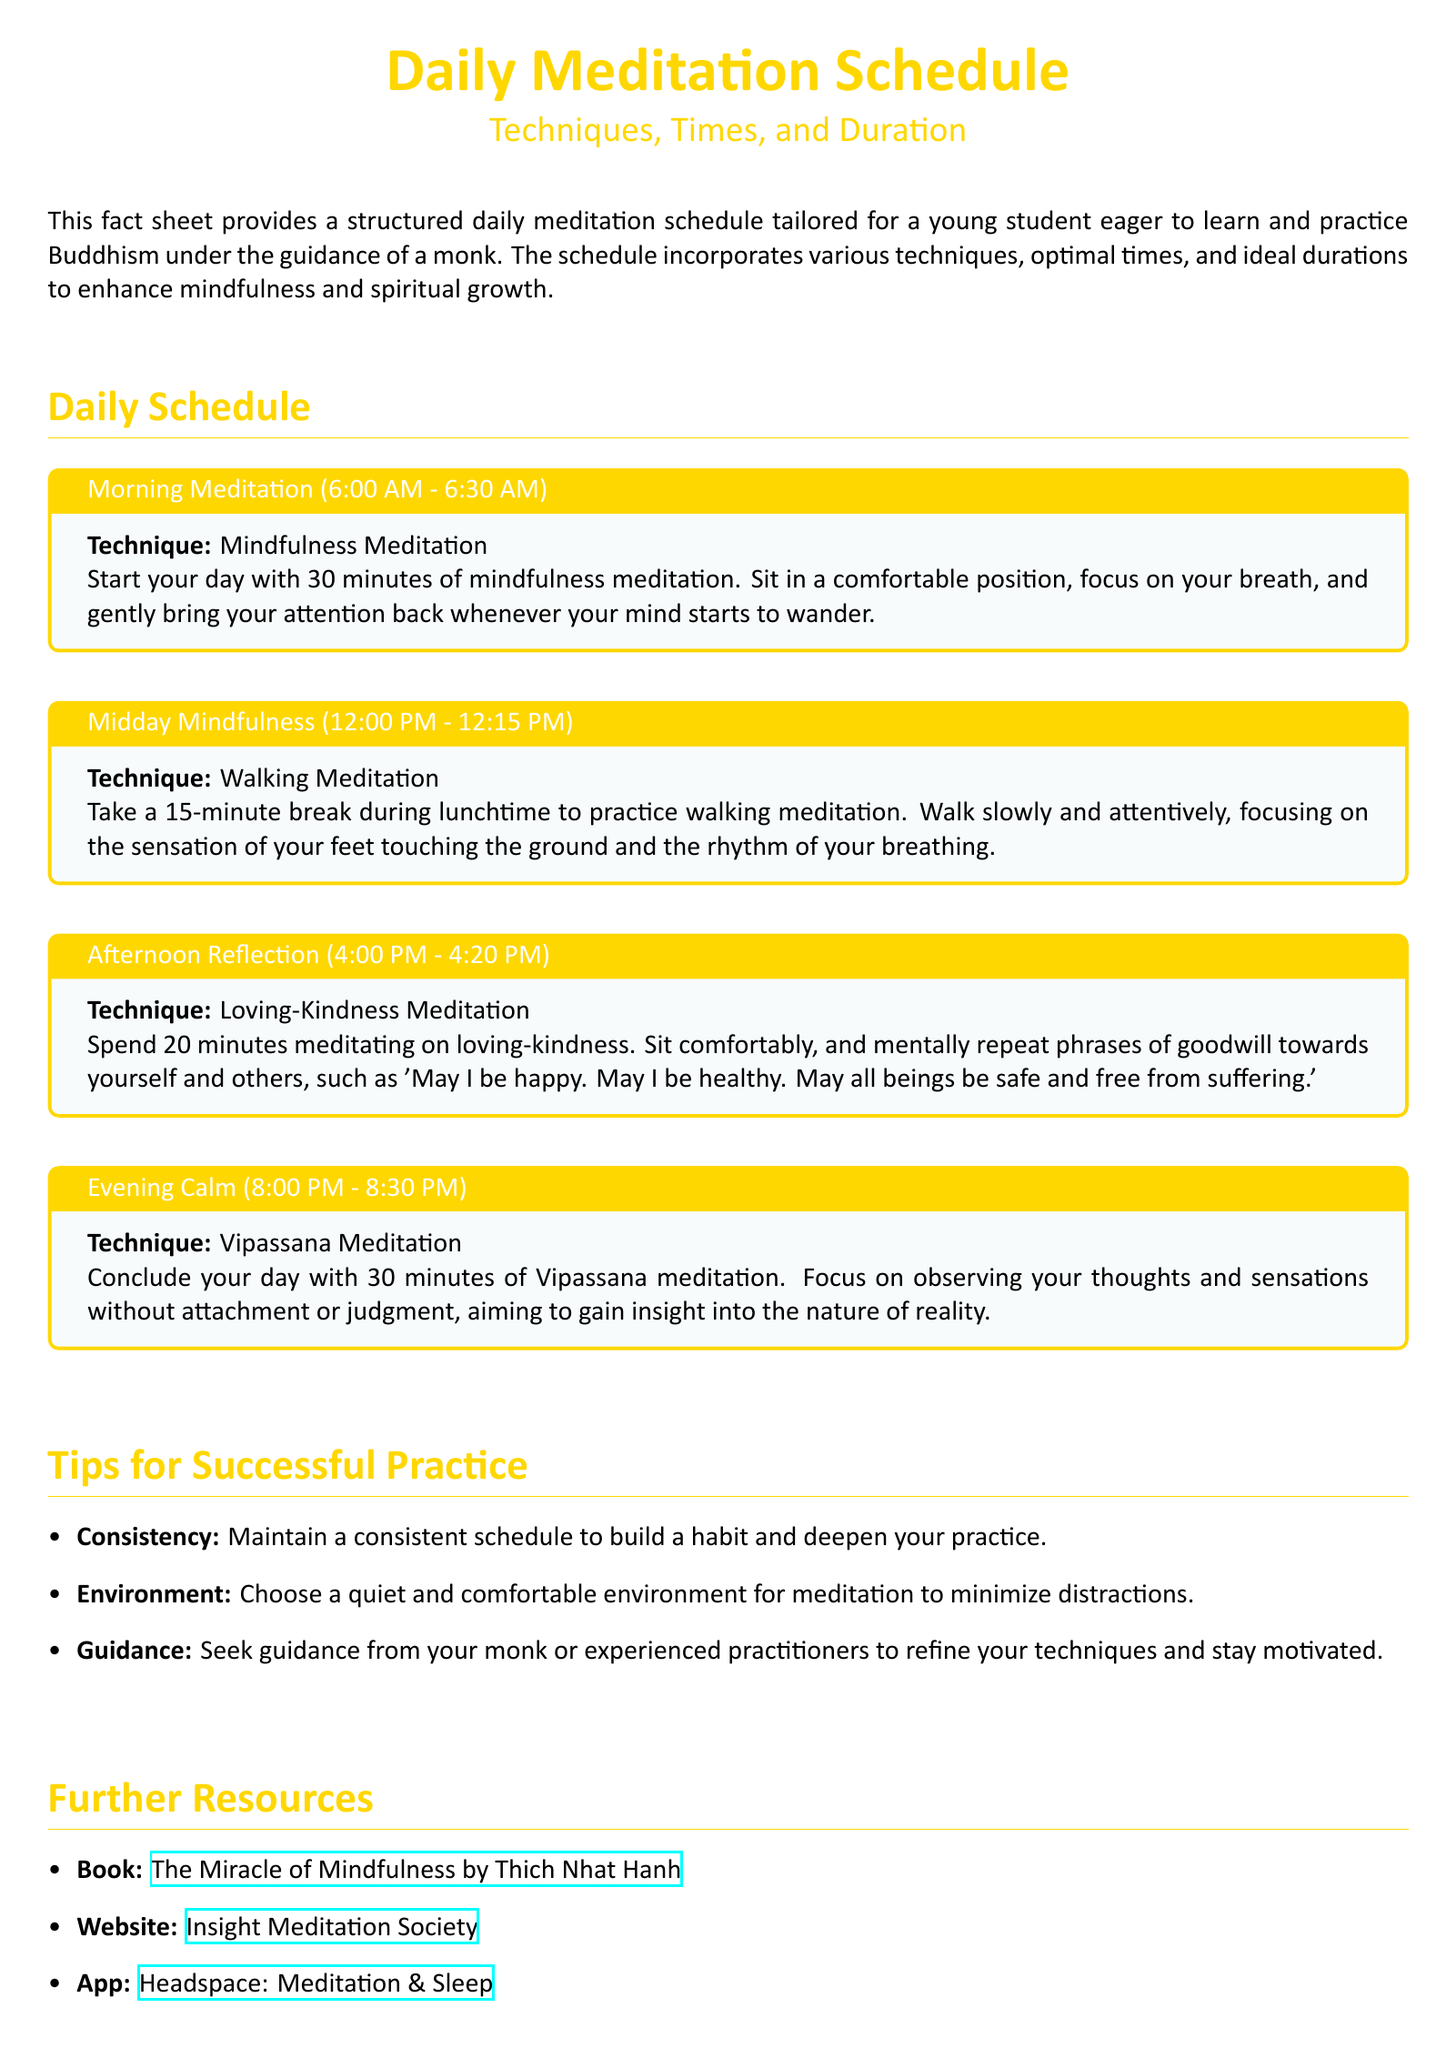What is the first meditation technique of the day? The first meditation technique listed in the schedule is Mindfulness Meditation, taking place in the morning.
Answer: Mindfulness Meditation What time does the Midday Mindfulness meditation start? The Midday Mindfulness meditation starts at 12:00 PM as indicated in the schedule.
Answer: 12:00 PM How long is the Afternoon Reflection session? The Afternoon Reflection session lasts for 20 minutes as specified in the document.
Answer: 20 minutes What technique is practiced during the Evening Calm? The meditation technique practiced during the Evening Calm is Vipassana Meditation, mentioned in the evening section.
Answer: Vipassana Meditation What is emphasized for successful practice? Consistency is emphasized as an important aspect for successful meditation practice according to the Tips for Successful Practice section.
Answer: Consistency What type of meditation is suggested for the Afternoon Reflection time? The technique suggested for the Afternoon Reflection time is Loving-Kindness Meditation according to the schedule.
Answer: Loving-Kindness Meditation What is a recommended resource mentioned for further reading? The book "The Miracle of Mindfulness" by Thich Nhat Hanh is listed as a recommended resource.
Answer: The Miracle of Mindfulness How long is the mindfulness session in the morning? The mindfulness session in the morning lasts for 30 minutes as stated in the document.
Answer: 30 minutes What environment is suggested for meditation practice? The document suggests a quiet and comfortable environment for meditation to reduce distractions.
Answer: Quiet and comfortable environment 